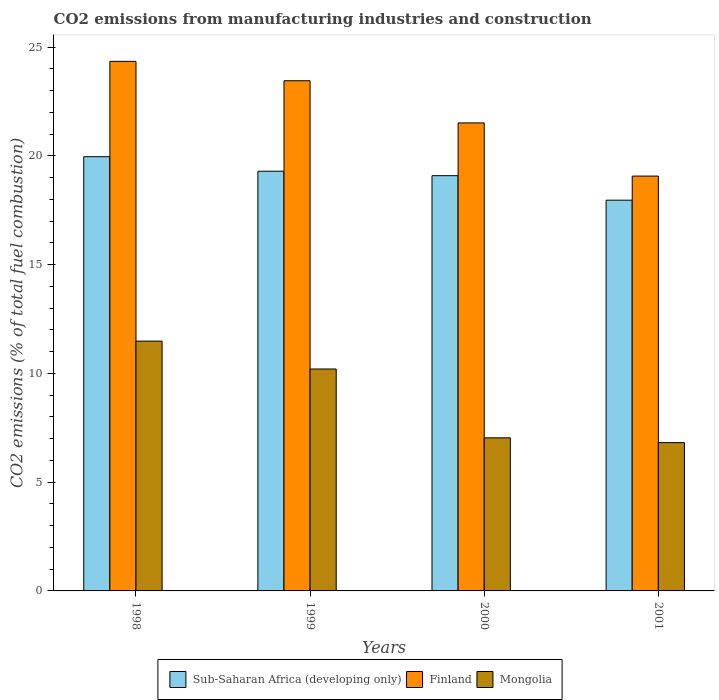How many groups of bars are there?
Make the answer very short. 4. Are the number of bars per tick equal to the number of legend labels?
Offer a terse response. Yes. How many bars are there on the 2nd tick from the right?
Your answer should be very brief. 3. What is the amount of CO2 emitted in Finland in 1998?
Offer a terse response. 24.34. Across all years, what is the maximum amount of CO2 emitted in Sub-Saharan Africa (developing only)?
Provide a succinct answer. 19.96. Across all years, what is the minimum amount of CO2 emitted in Mongolia?
Keep it short and to the point. 6.82. In which year was the amount of CO2 emitted in Mongolia minimum?
Offer a very short reply. 2001. What is the total amount of CO2 emitted in Sub-Saharan Africa (developing only) in the graph?
Provide a succinct answer. 76.3. What is the difference between the amount of CO2 emitted in Finland in 1998 and that in 2000?
Provide a succinct answer. 2.83. What is the difference between the amount of CO2 emitted in Finland in 2000 and the amount of CO2 emitted in Sub-Saharan Africa (developing only) in 1998?
Keep it short and to the point. 1.55. What is the average amount of CO2 emitted in Sub-Saharan Africa (developing only) per year?
Offer a very short reply. 19.08. In the year 1999, what is the difference between the amount of CO2 emitted in Finland and amount of CO2 emitted in Sub-Saharan Africa (developing only)?
Ensure brevity in your answer.  4.16. What is the ratio of the amount of CO2 emitted in Finland in 1999 to that in 2000?
Make the answer very short. 1.09. Is the amount of CO2 emitted in Sub-Saharan Africa (developing only) in 1998 less than that in 1999?
Your answer should be compact. No. Is the difference between the amount of CO2 emitted in Finland in 1999 and 2000 greater than the difference between the amount of CO2 emitted in Sub-Saharan Africa (developing only) in 1999 and 2000?
Make the answer very short. Yes. What is the difference between the highest and the second highest amount of CO2 emitted in Mongolia?
Give a very brief answer. 1.28. What is the difference between the highest and the lowest amount of CO2 emitted in Sub-Saharan Africa (developing only)?
Your response must be concise. 2. Is the sum of the amount of CO2 emitted in Sub-Saharan Africa (developing only) in 1998 and 2001 greater than the maximum amount of CO2 emitted in Mongolia across all years?
Provide a succinct answer. Yes. What does the 1st bar from the left in 2001 represents?
Keep it short and to the point. Sub-Saharan Africa (developing only). What does the 1st bar from the right in 1999 represents?
Provide a succinct answer. Mongolia. Is it the case that in every year, the sum of the amount of CO2 emitted in Sub-Saharan Africa (developing only) and amount of CO2 emitted in Mongolia is greater than the amount of CO2 emitted in Finland?
Give a very brief answer. Yes. Are the values on the major ticks of Y-axis written in scientific E-notation?
Make the answer very short. No. How many legend labels are there?
Provide a succinct answer. 3. How are the legend labels stacked?
Make the answer very short. Horizontal. What is the title of the graph?
Your answer should be very brief. CO2 emissions from manufacturing industries and construction. What is the label or title of the Y-axis?
Give a very brief answer. CO2 emissions (% of total fuel combustion). What is the CO2 emissions (% of total fuel combustion) in Sub-Saharan Africa (developing only) in 1998?
Provide a succinct answer. 19.96. What is the CO2 emissions (% of total fuel combustion) of Finland in 1998?
Provide a short and direct response. 24.34. What is the CO2 emissions (% of total fuel combustion) of Mongolia in 1998?
Your response must be concise. 11.48. What is the CO2 emissions (% of total fuel combustion) of Sub-Saharan Africa (developing only) in 1999?
Provide a short and direct response. 19.29. What is the CO2 emissions (% of total fuel combustion) in Finland in 1999?
Give a very brief answer. 23.45. What is the CO2 emissions (% of total fuel combustion) in Mongolia in 1999?
Provide a succinct answer. 10.2. What is the CO2 emissions (% of total fuel combustion) in Sub-Saharan Africa (developing only) in 2000?
Make the answer very short. 19.09. What is the CO2 emissions (% of total fuel combustion) of Finland in 2000?
Ensure brevity in your answer.  21.51. What is the CO2 emissions (% of total fuel combustion) in Mongolia in 2000?
Your answer should be very brief. 7.04. What is the CO2 emissions (% of total fuel combustion) of Sub-Saharan Africa (developing only) in 2001?
Provide a succinct answer. 17.96. What is the CO2 emissions (% of total fuel combustion) of Finland in 2001?
Provide a succinct answer. 19.07. What is the CO2 emissions (% of total fuel combustion) of Mongolia in 2001?
Your answer should be compact. 6.82. Across all years, what is the maximum CO2 emissions (% of total fuel combustion) of Sub-Saharan Africa (developing only)?
Keep it short and to the point. 19.96. Across all years, what is the maximum CO2 emissions (% of total fuel combustion) of Finland?
Your answer should be compact. 24.34. Across all years, what is the maximum CO2 emissions (% of total fuel combustion) of Mongolia?
Keep it short and to the point. 11.48. Across all years, what is the minimum CO2 emissions (% of total fuel combustion) of Sub-Saharan Africa (developing only)?
Your response must be concise. 17.96. Across all years, what is the minimum CO2 emissions (% of total fuel combustion) of Finland?
Ensure brevity in your answer.  19.07. Across all years, what is the minimum CO2 emissions (% of total fuel combustion) in Mongolia?
Provide a short and direct response. 6.82. What is the total CO2 emissions (% of total fuel combustion) in Sub-Saharan Africa (developing only) in the graph?
Ensure brevity in your answer.  76.3. What is the total CO2 emissions (% of total fuel combustion) in Finland in the graph?
Your answer should be compact. 88.38. What is the total CO2 emissions (% of total fuel combustion) of Mongolia in the graph?
Make the answer very short. 35.54. What is the difference between the CO2 emissions (% of total fuel combustion) in Sub-Saharan Africa (developing only) in 1998 and that in 1999?
Your answer should be very brief. 0.67. What is the difference between the CO2 emissions (% of total fuel combustion) of Finland in 1998 and that in 1999?
Offer a very short reply. 0.89. What is the difference between the CO2 emissions (% of total fuel combustion) in Mongolia in 1998 and that in 1999?
Ensure brevity in your answer.  1.28. What is the difference between the CO2 emissions (% of total fuel combustion) of Sub-Saharan Africa (developing only) in 1998 and that in 2000?
Give a very brief answer. 0.87. What is the difference between the CO2 emissions (% of total fuel combustion) in Finland in 1998 and that in 2000?
Your response must be concise. 2.83. What is the difference between the CO2 emissions (% of total fuel combustion) of Mongolia in 1998 and that in 2000?
Offer a terse response. 4.45. What is the difference between the CO2 emissions (% of total fuel combustion) in Sub-Saharan Africa (developing only) in 1998 and that in 2001?
Your response must be concise. 2. What is the difference between the CO2 emissions (% of total fuel combustion) in Finland in 1998 and that in 2001?
Keep it short and to the point. 5.27. What is the difference between the CO2 emissions (% of total fuel combustion) in Mongolia in 1998 and that in 2001?
Provide a short and direct response. 4.67. What is the difference between the CO2 emissions (% of total fuel combustion) in Sub-Saharan Africa (developing only) in 1999 and that in 2000?
Provide a short and direct response. 0.21. What is the difference between the CO2 emissions (% of total fuel combustion) in Finland in 1999 and that in 2000?
Your response must be concise. 1.94. What is the difference between the CO2 emissions (% of total fuel combustion) in Mongolia in 1999 and that in 2000?
Keep it short and to the point. 3.16. What is the difference between the CO2 emissions (% of total fuel combustion) in Sub-Saharan Africa (developing only) in 1999 and that in 2001?
Ensure brevity in your answer.  1.33. What is the difference between the CO2 emissions (% of total fuel combustion) of Finland in 1999 and that in 2001?
Your response must be concise. 4.38. What is the difference between the CO2 emissions (% of total fuel combustion) in Mongolia in 1999 and that in 2001?
Keep it short and to the point. 3.38. What is the difference between the CO2 emissions (% of total fuel combustion) in Sub-Saharan Africa (developing only) in 2000 and that in 2001?
Your answer should be compact. 1.13. What is the difference between the CO2 emissions (% of total fuel combustion) in Finland in 2000 and that in 2001?
Offer a terse response. 2.44. What is the difference between the CO2 emissions (% of total fuel combustion) in Mongolia in 2000 and that in 2001?
Your response must be concise. 0.22. What is the difference between the CO2 emissions (% of total fuel combustion) of Sub-Saharan Africa (developing only) in 1998 and the CO2 emissions (% of total fuel combustion) of Finland in 1999?
Make the answer very short. -3.49. What is the difference between the CO2 emissions (% of total fuel combustion) of Sub-Saharan Africa (developing only) in 1998 and the CO2 emissions (% of total fuel combustion) of Mongolia in 1999?
Your answer should be very brief. 9.76. What is the difference between the CO2 emissions (% of total fuel combustion) of Finland in 1998 and the CO2 emissions (% of total fuel combustion) of Mongolia in 1999?
Your answer should be very brief. 14.14. What is the difference between the CO2 emissions (% of total fuel combustion) of Sub-Saharan Africa (developing only) in 1998 and the CO2 emissions (% of total fuel combustion) of Finland in 2000?
Ensure brevity in your answer.  -1.55. What is the difference between the CO2 emissions (% of total fuel combustion) in Sub-Saharan Africa (developing only) in 1998 and the CO2 emissions (% of total fuel combustion) in Mongolia in 2000?
Your answer should be compact. 12.92. What is the difference between the CO2 emissions (% of total fuel combustion) of Finland in 1998 and the CO2 emissions (% of total fuel combustion) of Mongolia in 2000?
Provide a short and direct response. 17.31. What is the difference between the CO2 emissions (% of total fuel combustion) of Sub-Saharan Africa (developing only) in 1998 and the CO2 emissions (% of total fuel combustion) of Finland in 2001?
Provide a short and direct response. 0.89. What is the difference between the CO2 emissions (% of total fuel combustion) in Sub-Saharan Africa (developing only) in 1998 and the CO2 emissions (% of total fuel combustion) in Mongolia in 2001?
Your answer should be compact. 13.14. What is the difference between the CO2 emissions (% of total fuel combustion) of Finland in 1998 and the CO2 emissions (% of total fuel combustion) of Mongolia in 2001?
Your response must be concise. 17.53. What is the difference between the CO2 emissions (% of total fuel combustion) of Sub-Saharan Africa (developing only) in 1999 and the CO2 emissions (% of total fuel combustion) of Finland in 2000?
Keep it short and to the point. -2.22. What is the difference between the CO2 emissions (% of total fuel combustion) of Sub-Saharan Africa (developing only) in 1999 and the CO2 emissions (% of total fuel combustion) of Mongolia in 2000?
Offer a very short reply. 12.26. What is the difference between the CO2 emissions (% of total fuel combustion) of Finland in 1999 and the CO2 emissions (% of total fuel combustion) of Mongolia in 2000?
Offer a very short reply. 16.42. What is the difference between the CO2 emissions (% of total fuel combustion) in Sub-Saharan Africa (developing only) in 1999 and the CO2 emissions (% of total fuel combustion) in Finland in 2001?
Provide a succinct answer. 0.22. What is the difference between the CO2 emissions (% of total fuel combustion) in Sub-Saharan Africa (developing only) in 1999 and the CO2 emissions (% of total fuel combustion) in Mongolia in 2001?
Offer a very short reply. 12.47. What is the difference between the CO2 emissions (% of total fuel combustion) of Finland in 1999 and the CO2 emissions (% of total fuel combustion) of Mongolia in 2001?
Make the answer very short. 16.63. What is the difference between the CO2 emissions (% of total fuel combustion) of Sub-Saharan Africa (developing only) in 2000 and the CO2 emissions (% of total fuel combustion) of Finland in 2001?
Give a very brief answer. 0.02. What is the difference between the CO2 emissions (% of total fuel combustion) in Sub-Saharan Africa (developing only) in 2000 and the CO2 emissions (% of total fuel combustion) in Mongolia in 2001?
Make the answer very short. 12.27. What is the difference between the CO2 emissions (% of total fuel combustion) of Finland in 2000 and the CO2 emissions (% of total fuel combustion) of Mongolia in 2001?
Your response must be concise. 14.7. What is the average CO2 emissions (% of total fuel combustion) in Sub-Saharan Africa (developing only) per year?
Give a very brief answer. 19.08. What is the average CO2 emissions (% of total fuel combustion) in Finland per year?
Provide a short and direct response. 22.1. What is the average CO2 emissions (% of total fuel combustion) in Mongolia per year?
Offer a very short reply. 8.89. In the year 1998, what is the difference between the CO2 emissions (% of total fuel combustion) of Sub-Saharan Africa (developing only) and CO2 emissions (% of total fuel combustion) of Finland?
Offer a very short reply. -4.38. In the year 1998, what is the difference between the CO2 emissions (% of total fuel combustion) in Sub-Saharan Africa (developing only) and CO2 emissions (% of total fuel combustion) in Mongolia?
Give a very brief answer. 8.48. In the year 1998, what is the difference between the CO2 emissions (% of total fuel combustion) of Finland and CO2 emissions (% of total fuel combustion) of Mongolia?
Your answer should be compact. 12.86. In the year 1999, what is the difference between the CO2 emissions (% of total fuel combustion) of Sub-Saharan Africa (developing only) and CO2 emissions (% of total fuel combustion) of Finland?
Offer a very short reply. -4.16. In the year 1999, what is the difference between the CO2 emissions (% of total fuel combustion) of Sub-Saharan Africa (developing only) and CO2 emissions (% of total fuel combustion) of Mongolia?
Offer a terse response. 9.09. In the year 1999, what is the difference between the CO2 emissions (% of total fuel combustion) of Finland and CO2 emissions (% of total fuel combustion) of Mongolia?
Offer a terse response. 13.25. In the year 2000, what is the difference between the CO2 emissions (% of total fuel combustion) in Sub-Saharan Africa (developing only) and CO2 emissions (% of total fuel combustion) in Finland?
Your answer should be very brief. -2.43. In the year 2000, what is the difference between the CO2 emissions (% of total fuel combustion) in Sub-Saharan Africa (developing only) and CO2 emissions (% of total fuel combustion) in Mongolia?
Your answer should be compact. 12.05. In the year 2000, what is the difference between the CO2 emissions (% of total fuel combustion) of Finland and CO2 emissions (% of total fuel combustion) of Mongolia?
Your response must be concise. 14.48. In the year 2001, what is the difference between the CO2 emissions (% of total fuel combustion) of Sub-Saharan Africa (developing only) and CO2 emissions (% of total fuel combustion) of Finland?
Make the answer very short. -1.11. In the year 2001, what is the difference between the CO2 emissions (% of total fuel combustion) of Sub-Saharan Africa (developing only) and CO2 emissions (% of total fuel combustion) of Mongolia?
Your response must be concise. 11.14. In the year 2001, what is the difference between the CO2 emissions (% of total fuel combustion) in Finland and CO2 emissions (% of total fuel combustion) in Mongolia?
Your response must be concise. 12.25. What is the ratio of the CO2 emissions (% of total fuel combustion) in Sub-Saharan Africa (developing only) in 1998 to that in 1999?
Keep it short and to the point. 1.03. What is the ratio of the CO2 emissions (% of total fuel combustion) in Finland in 1998 to that in 1999?
Offer a terse response. 1.04. What is the ratio of the CO2 emissions (% of total fuel combustion) of Mongolia in 1998 to that in 1999?
Your answer should be very brief. 1.13. What is the ratio of the CO2 emissions (% of total fuel combustion) in Sub-Saharan Africa (developing only) in 1998 to that in 2000?
Provide a short and direct response. 1.05. What is the ratio of the CO2 emissions (% of total fuel combustion) in Finland in 1998 to that in 2000?
Keep it short and to the point. 1.13. What is the ratio of the CO2 emissions (% of total fuel combustion) of Mongolia in 1998 to that in 2000?
Make the answer very short. 1.63. What is the ratio of the CO2 emissions (% of total fuel combustion) in Sub-Saharan Africa (developing only) in 1998 to that in 2001?
Offer a very short reply. 1.11. What is the ratio of the CO2 emissions (% of total fuel combustion) of Finland in 1998 to that in 2001?
Offer a very short reply. 1.28. What is the ratio of the CO2 emissions (% of total fuel combustion) of Mongolia in 1998 to that in 2001?
Your answer should be very brief. 1.68. What is the ratio of the CO2 emissions (% of total fuel combustion) in Sub-Saharan Africa (developing only) in 1999 to that in 2000?
Give a very brief answer. 1.01. What is the ratio of the CO2 emissions (% of total fuel combustion) of Finland in 1999 to that in 2000?
Your answer should be very brief. 1.09. What is the ratio of the CO2 emissions (% of total fuel combustion) of Mongolia in 1999 to that in 2000?
Make the answer very short. 1.45. What is the ratio of the CO2 emissions (% of total fuel combustion) in Sub-Saharan Africa (developing only) in 1999 to that in 2001?
Ensure brevity in your answer.  1.07. What is the ratio of the CO2 emissions (% of total fuel combustion) of Finland in 1999 to that in 2001?
Offer a very short reply. 1.23. What is the ratio of the CO2 emissions (% of total fuel combustion) of Mongolia in 1999 to that in 2001?
Offer a very short reply. 1.5. What is the ratio of the CO2 emissions (% of total fuel combustion) in Sub-Saharan Africa (developing only) in 2000 to that in 2001?
Give a very brief answer. 1.06. What is the ratio of the CO2 emissions (% of total fuel combustion) of Finland in 2000 to that in 2001?
Your answer should be very brief. 1.13. What is the ratio of the CO2 emissions (% of total fuel combustion) of Mongolia in 2000 to that in 2001?
Keep it short and to the point. 1.03. What is the difference between the highest and the second highest CO2 emissions (% of total fuel combustion) of Sub-Saharan Africa (developing only)?
Offer a very short reply. 0.67. What is the difference between the highest and the second highest CO2 emissions (% of total fuel combustion) of Finland?
Offer a terse response. 0.89. What is the difference between the highest and the second highest CO2 emissions (% of total fuel combustion) of Mongolia?
Keep it short and to the point. 1.28. What is the difference between the highest and the lowest CO2 emissions (% of total fuel combustion) of Sub-Saharan Africa (developing only)?
Give a very brief answer. 2. What is the difference between the highest and the lowest CO2 emissions (% of total fuel combustion) in Finland?
Your answer should be very brief. 5.27. What is the difference between the highest and the lowest CO2 emissions (% of total fuel combustion) of Mongolia?
Offer a terse response. 4.67. 